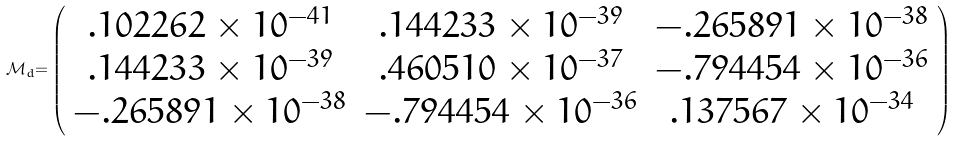Convert formula to latex. <formula><loc_0><loc_0><loc_500><loc_500>\mathcal { M _ { \mathnormal d } } \mathnormal = \left ( \begin{array} { c c c } . 1 0 2 2 6 2 \times 1 0 ^ { - 4 1 } & . 1 4 4 2 3 3 \times 1 0 ^ { - 3 9 } & - . 2 6 5 8 9 1 \times 1 0 ^ { - 3 8 } \\ . 1 4 4 2 3 3 \times 1 0 ^ { - 3 9 } & . 4 6 0 5 1 0 \times 1 0 ^ { - 3 7 } & - . 7 9 4 4 5 4 \times 1 0 ^ { - 3 6 } \\ - . 2 6 5 8 9 1 \times 1 0 ^ { - 3 8 } & - . 7 9 4 4 5 4 \times 1 0 ^ { - 3 6 } & . 1 3 7 5 6 7 \times 1 0 ^ { - 3 4 } \end{array} \right )</formula> 